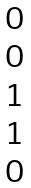<formula> <loc_0><loc_0><loc_500><loc_500>\begin{matrix} 0 \\ 0 \\ 1 \\ 1 \\ 0 \end{matrix}</formula> 